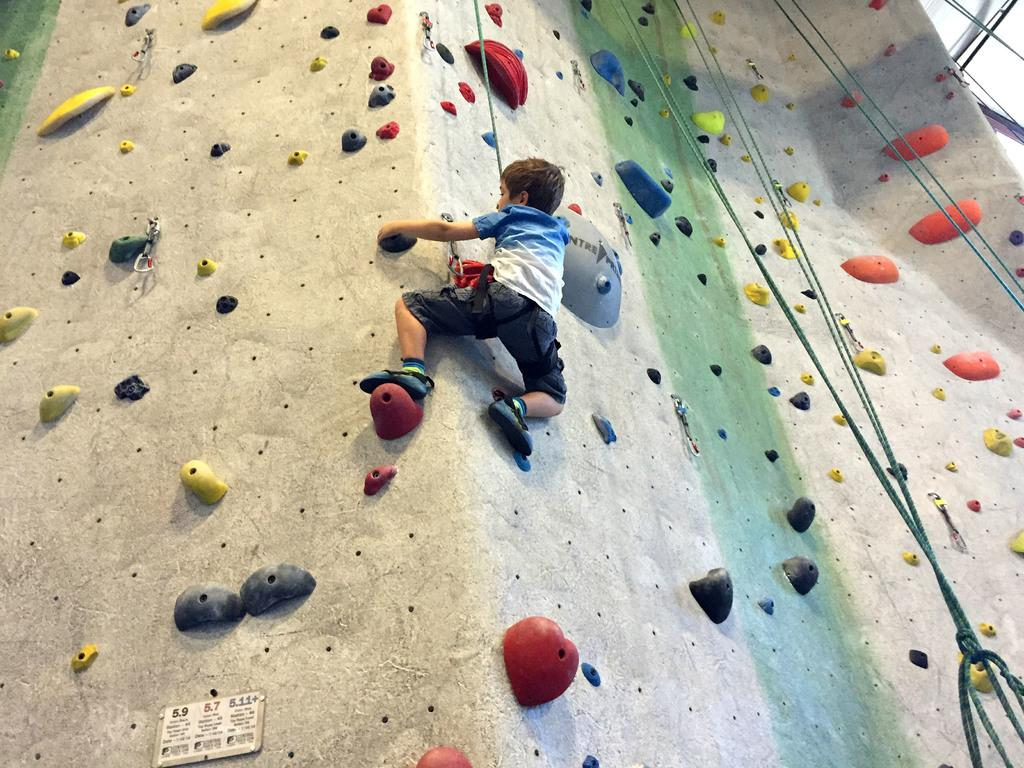What is the main subject of the image? There is a child in the image. What is the child doing in the image? The child is climbing on a wall. How is the child climbing the wall? The child is using a rope to climb. Can you describe the wall in the image? The wall has stones on it and there are other objects on the wall. Are there any other visible objects in the image besides the wall and the child? Yes, there are ropes and other objects visible in the image. What type of bone can be seen in the child's hand in the image? There is no bone visible in the child's hand or anywhere else in the image. Is there a bell ringing in the background of the image? There is no bell present or mentioned in the image. 